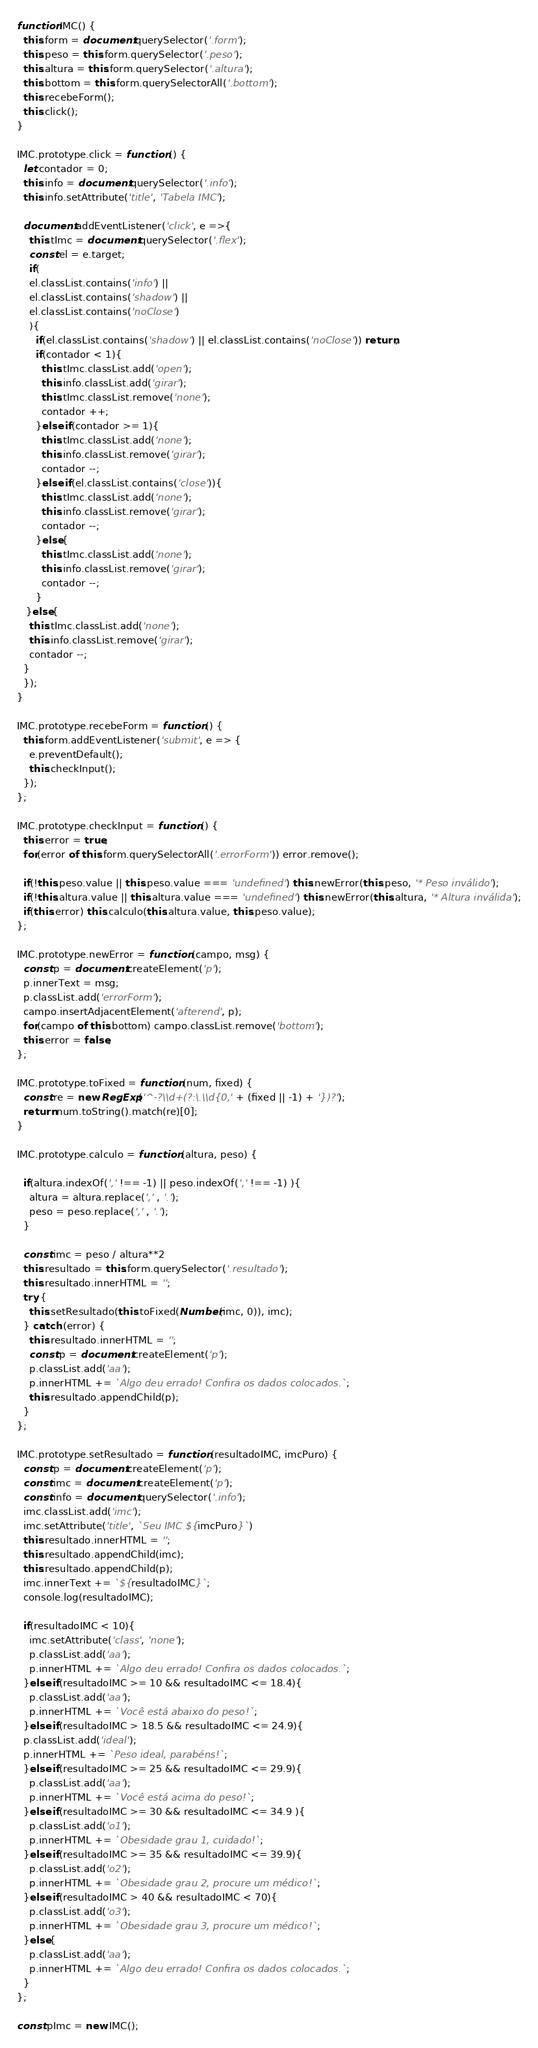Convert code to text. <code><loc_0><loc_0><loc_500><loc_500><_JavaScript_>function IMC() {
  this.form = document.querySelector('.form');
  this.peso = this.form.querySelector('.peso');
  this.altura = this.form.querySelector('.altura');
  this.bottom = this.form.querySelectorAll('.bottom');
  this.recebeForm();
  this.click();
}

IMC.prototype.click = function () {
  let contador = 0;
  this.info = document.querySelector('.info');
  this.info.setAttribute('title', 'Tabela IMC');
  
  document.addEventListener('click', e =>{
    this.tImc = document.querySelector('.flex');
    const el = e.target;
    if(
    el.classList.contains('info') || 
    el.classList.contains('shadow') || 
    el.classList.contains('noClose')
    ){
      if(el.classList.contains('shadow') || el.classList.contains('noClose')) return;
      if(contador < 1){
        this.tImc.classList.add('open');
        this.info.classList.add('girar');
        this.tImc.classList.remove('none');
        contador ++;
      }else if(contador >= 1){
        this.tImc.classList.add('none');
        this.info.classList.remove('girar');
        contador --;
      }else if(el.classList.contains('close')){
        this.tImc.classList.add('none');
        this.info.classList.remove('girar');
        contador --;
      }else{
        this.tImc.classList.add('none');
        this.info.classList.remove('girar');
        contador --;
      }
   }else{
    this.tImc.classList.add('none');
    this.info.classList.remove('girar');
    contador --;
  }
  });
}

IMC.prototype.recebeForm = function () {
  this.form.addEventListener('submit', e => {
    e.preventDefault();
    this.checkInput();
  });
};

IMC.prototype.checkInput = function () {
  this.error = true;
  for(error of this.form.querySelectorAll('.errorForm')) error.remove();

  if(!this.peso.value || this.peso.value === 'undefined') this.newError(this.peso, '* Peso inválido');
  if(!this.altura.value || this.altura.value === 'undefined') this.newError(this.altura, '* Altura inválida');
  if(this.error) this.calculo(this.altura.value, this.peso.value);
};

IMC.prototype.newError = function (campo, msg) {
  const p = document.createElement('p');
  p.innerText = msg;
  p.classList.add('errorForm');
  campo.insertAdjacentElement('afterend', p);
  for(campo of this.bottom) campo.classList.remove('bottom');
  this.error = false;
};

IMC.prototype.toFixed = function (num, fixed) {
  const re = new RegExp('^-?\\d+(?:\.\\d{0,' + (fixed || -1) + '})?');
  return num.toString().match(re)[0];
}

IMC.prototype.calculo = function (altura, peso) {
  
  if(altura.indexOf(',' !== -1) || peso.indexOf(',' !== -1) ){
    altura = altura.replace(',' , '.');
    peso = peso.replace(',' , '.');
  }

  const imc = peso / altura**2
  this.resultado = this.form.querySelector('.resultado');
  this.resultado.innerHTML = '';
  try {
    this.setResultado(this.toFixed(Number(imc, 0)), imc);
  } catch (error) {
    this.resultado.innerHTML = '';
    const p = document.createElement('p');
    p.classList.add('aa');
    p.innerHTML += `Algo deu errado! Confira os dados colocados.`;
    this.resultado.appendChild(p);
  }
};

IMC.prototype.setResultado = function (resultadoIMC, imcPuro) {
  const p = document.createElement('p');
  const imc = document.createElement('p');
  const info = document.querySelector('.info');
  imc.classList.add('imc');
  imc.setAttribute('title', `Seu IMC ${imcPuro}`)
  this.resultado.innerHTML = '';
  this.resultado.appendChild(imc);
  this.resultado.appendChild(p);
  imc.innerText += `${resultadoIMC}`;
  console.log(resultadoIMC);
  
  if(resultadoIMC < 10){
    imc.setAttribute('class', 'none');
    p.classList.add('aa');
    p.innerHTML += `Algo deu errado! Confira os dados colocados.`;
  }else if(resultadoIMC >= 10 && resultadoIMC <= 18.4){
    p.classList.add('aa');
    p.innerHTML += `Você está abaixo do peso!`;
  }else if(resultadoIMC > 18.5 && resultadoIMC <= 24.9){
  p.classList.add('ideal');
  p.innerHTML += `Peso ideal, parabéns!`;
  }else if(resultadoIMC >= 25 && resultadoIMC <= 29.9){
    p.classList.add('aa');
    p.innerHTML += `Você está acima do peso!`;
  }else if(resultadoIMC >= 30 && resultadoIMC <= 34.9 ){
    p.classList.add('o1');
    p.innerHTML += `Obesidade grau 1, cuidado!`;
  }else if(resultadoIMC >= 35 && resultadoIMC <= 39.9){
    p.classList.add('o2');
    p.innerHTML += `Obesidade grau 2, procure um médico!`;
  }else if(resultadoIMC > 40 && resultadoIMC < 70){
    p.classList.add('o3');
    p.innerHTML += `Obesidade grau 3, procure um médico!`;
  }else{
    p.classList.add('aa');
    p.innerHTML += `Algo deu errado! Confira os dados colocados.`;
  }
};

const pImc = new IMC();
</code> 